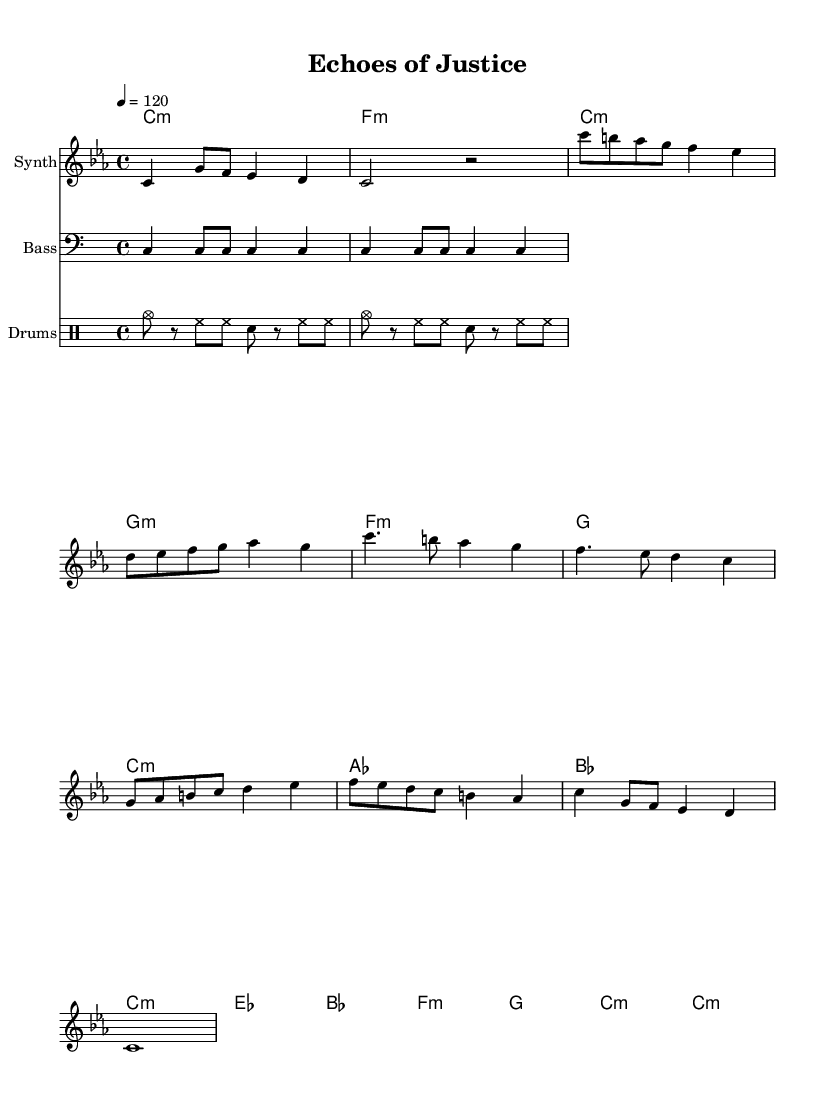What is the key signature of this music? The key signature is C minor, which has three flats (B, E, and A). This can be identified at the beginning of the sheet music where the key signature is indicated in the staff.
Answer: C minor What is the time signature of this composition? The time signature is 4/4, meaning there are four beats in each measure and the quarter note gets the beat. This is displayed at the beginning of the score.
Answer: 4/4 What is the tempo marking for this piece? The tempo marking is 120 beats per minute, which is indicated in the score as "4 = 120." This direction provides the speed at which the piece should be performed.
Answer: 120 How many measures are there in the melody section? To determine the number of measures, we count each segment divided by the vertical bar lines in the melody. There are a total of 10 measures in the provided melody section.
Answer: 10 What instruments are used in this composition? The composition includes three instruments: Synth, Bass, and Drums. These instruments are clearly labeled at the start of their respective staves.
Answer: Synth, Bass, Drums Which section introduces a change in harmony that includes diminished chords? The chorus section introduces harmony that consists of a mixture of major and minor chords, specifically indicated by "c:m" and includes diminished feelings. This complexity is characteristic of the emotional weight in experimental electronic music.
Answer: Chorus In what section do the courtroom recordings samples likely fit in? The bridge section is commonly where unexpected audio samples might be integrated. This section has a different melodic contour and might serve to contrast the rest of the piece, aligning with the experimental electronic approach to incorporate non-traditional sounds.
Answer: Bridge 